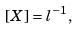<formula> <loc_0><loc_0><loc_500><loc_500>[ X ] = l ^ { - 1 } ,</formula> 